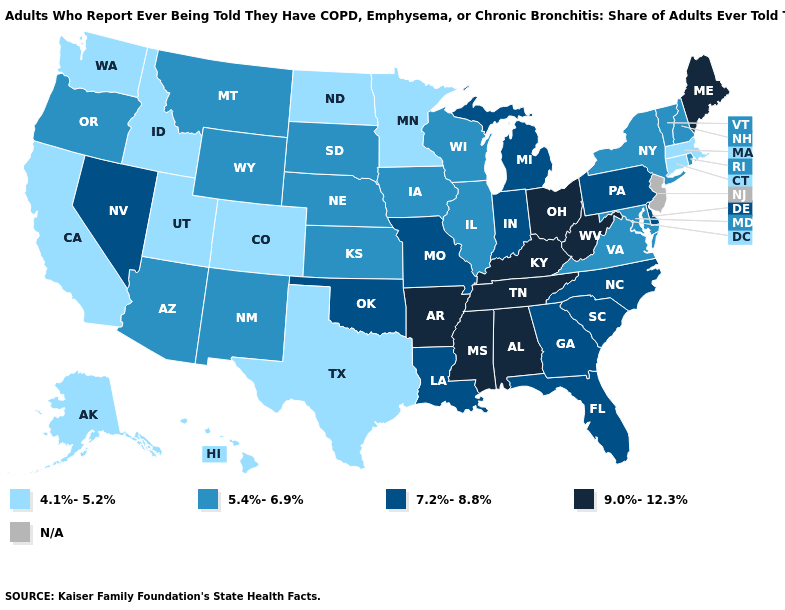Name the states that have a value in the range 5.4%-6.9%?
Write a very short answer. Arizona, Illinois, Iowa, Kansas, Maryland, Montana, Nebraska, New Hampshire, New Mexico, New York, Oregon, Rhode Island, South Dakota, Vermont, Virginia, Wisconsin, Wyoming. Name the states that have a value in the range 5.4%-6.9%?
Short answer required. Arizona, Illinois, Iowa, Kansas, Maryland, Montana, Nebraska, New Hampshire, New Mexico, New York, Oregon, Rhode Island, South Dakota, Vermont, Virginia, Wisconsin, Wyoming. Which states hav the highest value in the Northeast?
Give a very brief answer. Maine. Name the states that have a value in the range 7.2%-8.8%?
Short answer required. Delaware, Florida, Georgia, Indiana, Louisiana, Michigan, Missouri, Nevada, North Carolina, Oklahoma, Pennsylvania, South Carolina. What is the value of Tennessee?
Concise answer only. 9.0%-12.3%. Does Iowa have the highest value in the MidWest?
Keep it brief. No. What is the value of New Hampshire?
Keep it brief. 5.4%-6.9%. Name the states that have a value in the range N/A?
Short answer required. New Jersey. Name the states that have a value in the range 9.0%-12.3%?
Answer briefly. Alabama, Arkansas, Kentucky, Maine, Mississippi, Ohio, Tennessee, West Virginia. What is the value of New Jersey?
Short answer required. N/A. What is the highest value in the USA?
Keep it brief. 9.0%-12.3%. What is the value of Arkansas?
Give a very brief answer. 9.0%-12.3%. What is the value of Maine?
Quick response, please. 9.0%-12.3%. What is the value of Connecticut?
Keep it brief. 4.1%-5.2%. Does Tennessee have the lowest value in the USA?
Keep it brief. No. 